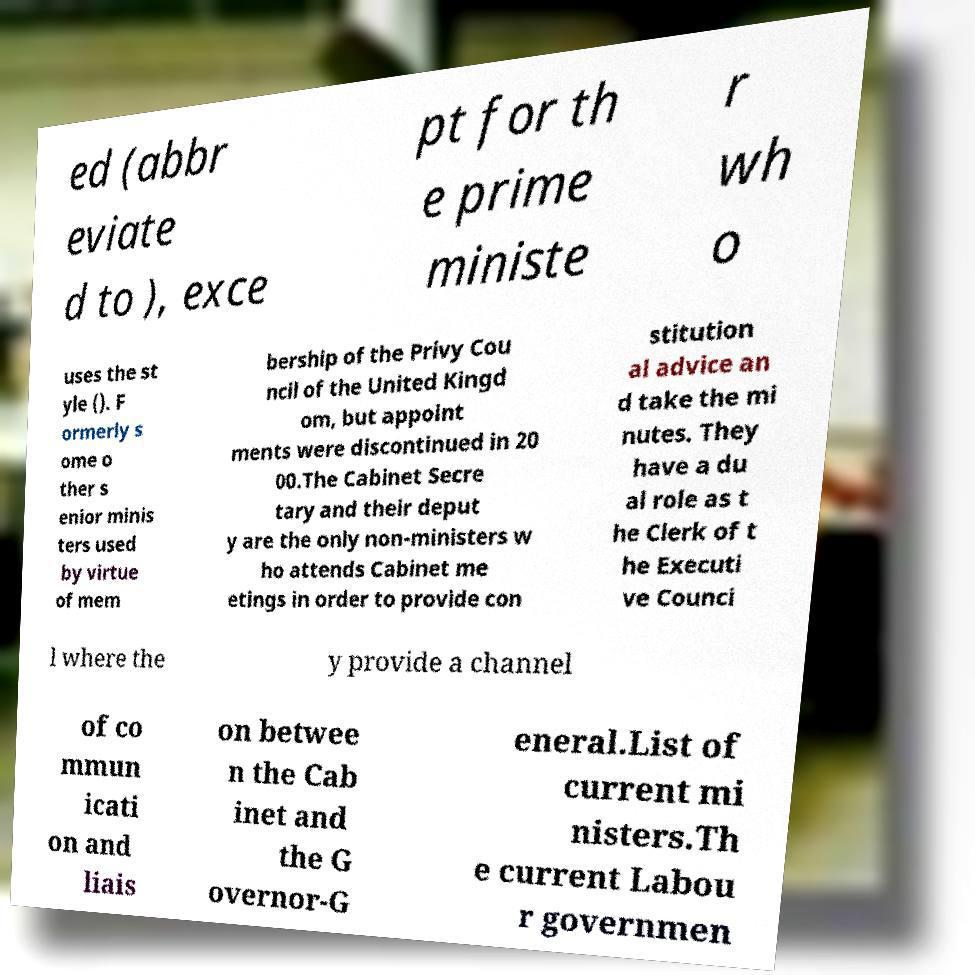I need the written content from this picture converted into text. Can you do that? ed (abbr eviate d to ), exce pt for th e prime ministe r wh o uses the st yle (). F ormerly s ome o ther s enior minis ters used by virtue of mem bership of the Privy Cou ncil of the United Kingd om, but appoint ments were discontinued in 20 00.The Cabinet Secre tary and their deput y are the only non-ministers w ho attends Cabinet me etings in order to provide con stitution al advice an d take the mi nutes. They have a du al role as t he Clerk of t he Executi ve Counci l where the y provide a channel of co mmun icati on and liais on betwee n the Cab inet and the G overnor-G eneral.List of current mi nisters.Th e current Labou r governmen 